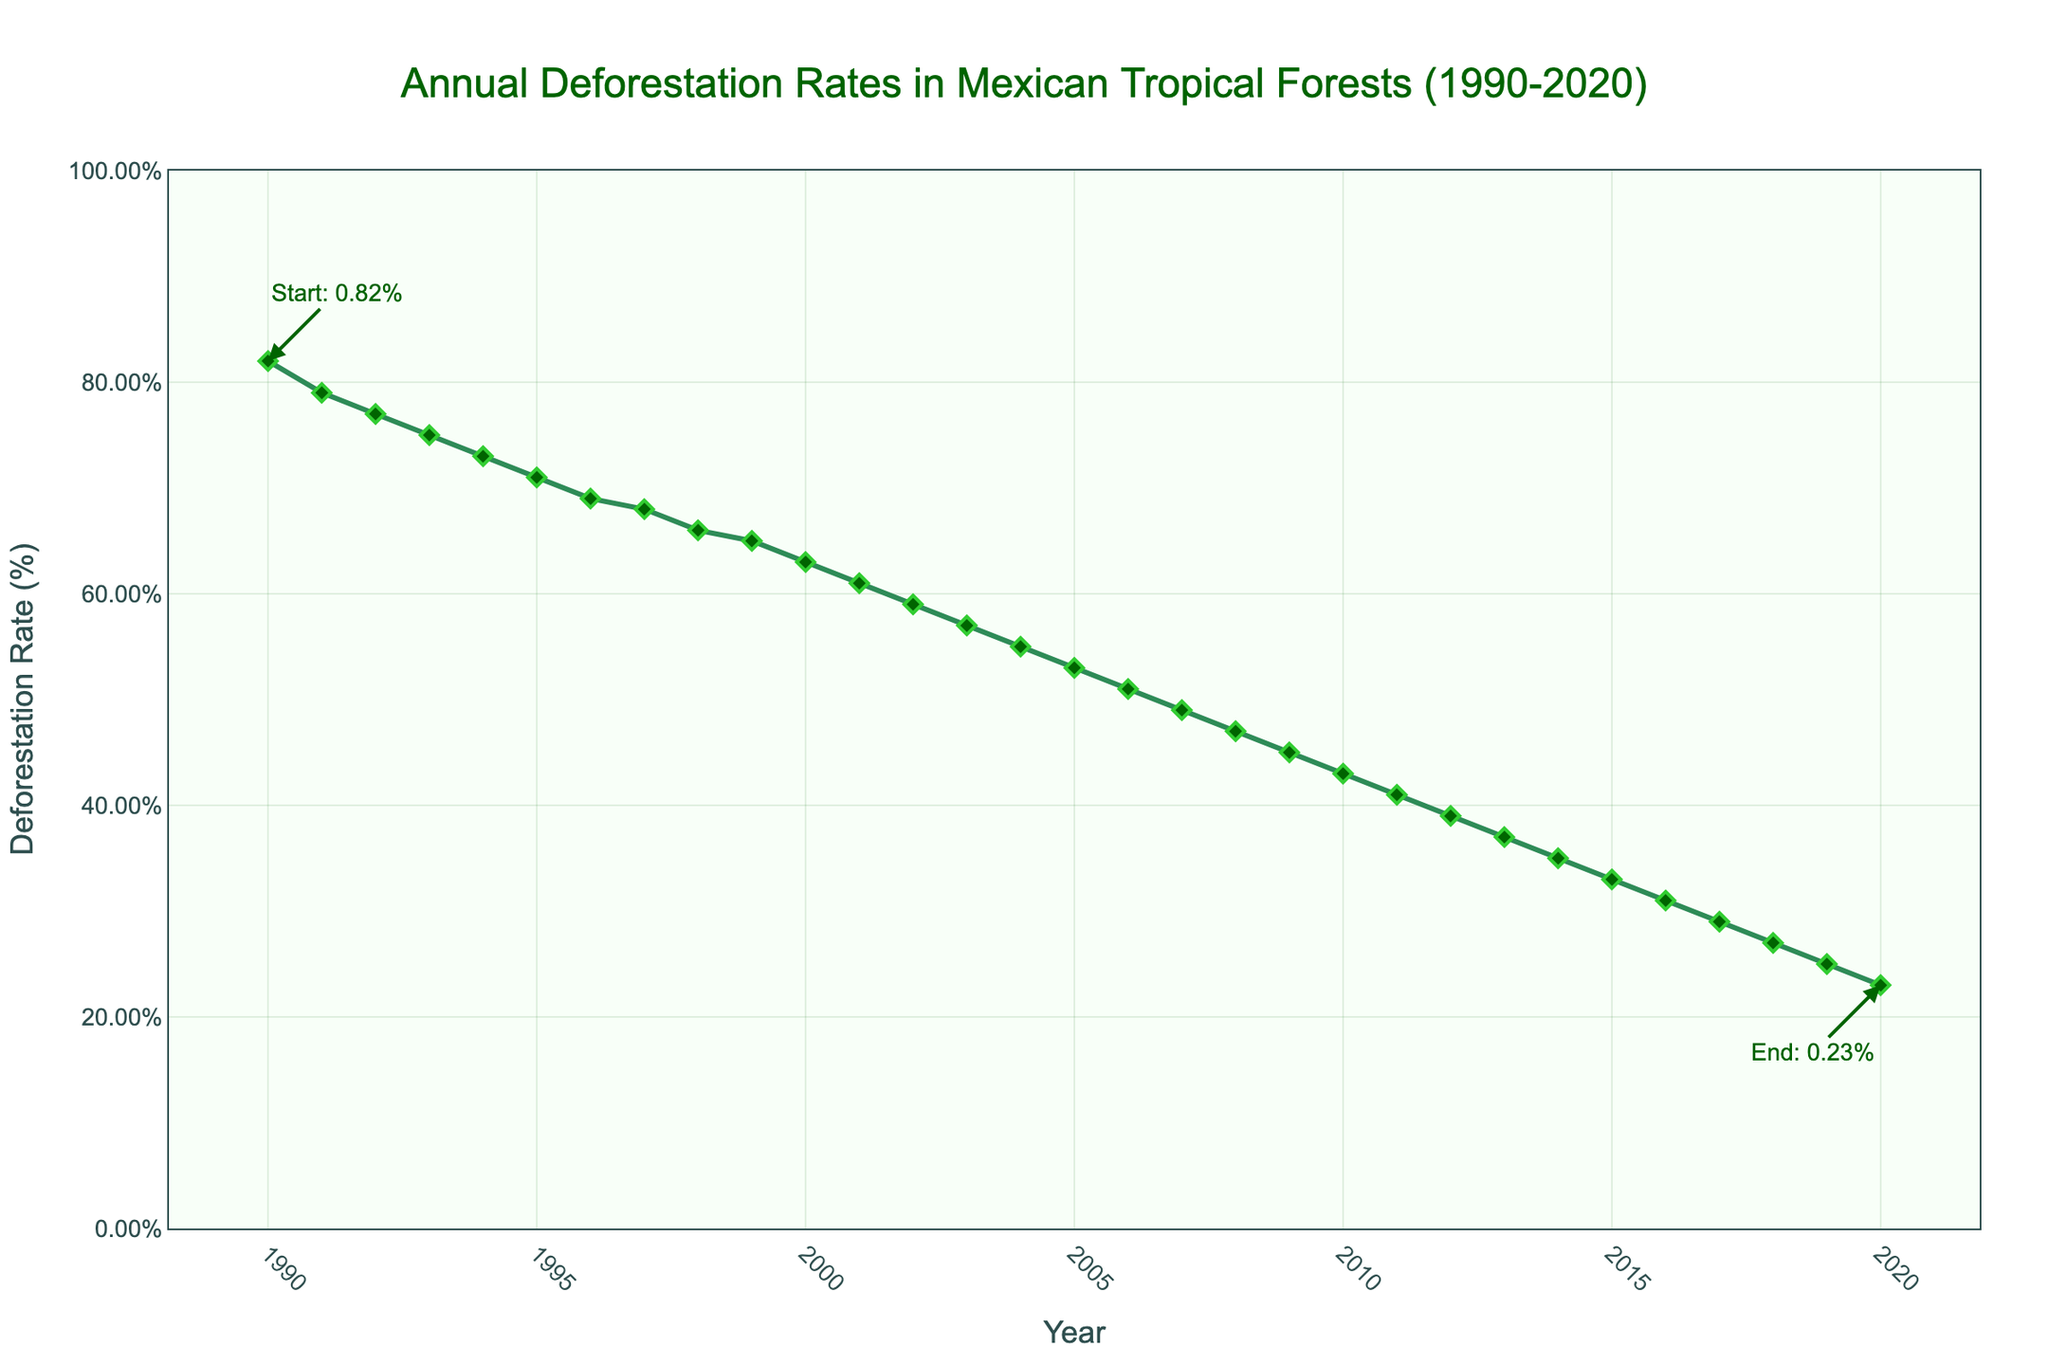what is the deforestation rate in 2010? The y-axis shows deforestation rates, and the x-axis shows the years. Locate 2010 on the x-axis and find the corresponding y-value. The rate for 2010 is 0.43%.
Answer: 0.43% Which year had a higher deforestation rate, 1995 or 2005? Compare the y-values for 1995 and 2005 by finding their corresponding points on the x-axis. In 1995, the rate is 0.71%, while in 2005, the rate is 0.53%. 1995 had a higher rate.
Answer: 1995 Calculate the average deforestation rate for the years 1990, 1995, 2000, 2005, 2010, 2015, and 2020. Sum the deforestation rates for these years and divide by the number of years. (0.82% + 0.71% + 0.63% + 0.53% + 0.43% + 0.33% + 0.23%) / 7 = 0.5243%.
Answer: 0.5243% How much did the deforestation rate decrease between 1990 and 2020? Subtract the deforestation rate in 2020 from that in 1990. 0.82% - 0.23% = 0.59%.
Answer: 0.59% Which year marks the lowest deforestation rate? Locate the lowest point on the y-axis and note the corresponding year on the x-axis. 2020 marks the lowest rate at 0.23%.
Answer: 2020 What is the general trend in deforestation rates from 1990 to 2020? Observe the overall direction of the line from left to right. The line declines, indicating a general decrease in deforestation rates.
Answer: Decreasing Compare the deforestation rates in 1990 and 2000. Which one is lower and by how much? The rate for 1990 is 0.82% and for 2000 is 0.63%. Subtract 0.63% from 0.82% to find the difference. The rate in 2000 is lower by 0.19%.
Answer: 2000, by 0.19% What is the median deforestation rate for the 30-year period? The median is the middle value in an ordered list. There are 31 values, so the median is the 16th value. The deforestation rate for the 16th year (2005) is 0.53%.
Answer: 0.53% Describe the change in deforestation rate from 2007 to 2013. Note the deforestation rates in 2007 (0.49%) and 2013 (0.37%) and observe the trend between these years. The rate consistently decreases from 0.49% to 0.37%.
Answer: Consistently decreases Is there any year where the deforestation rate remained the same as the previous year? Examine the plot for any flat (horizontal) lines, which would indicate no change. Based on the data, all years show a decrease, meaning no years had the same rate consecutively.
Answer: No 